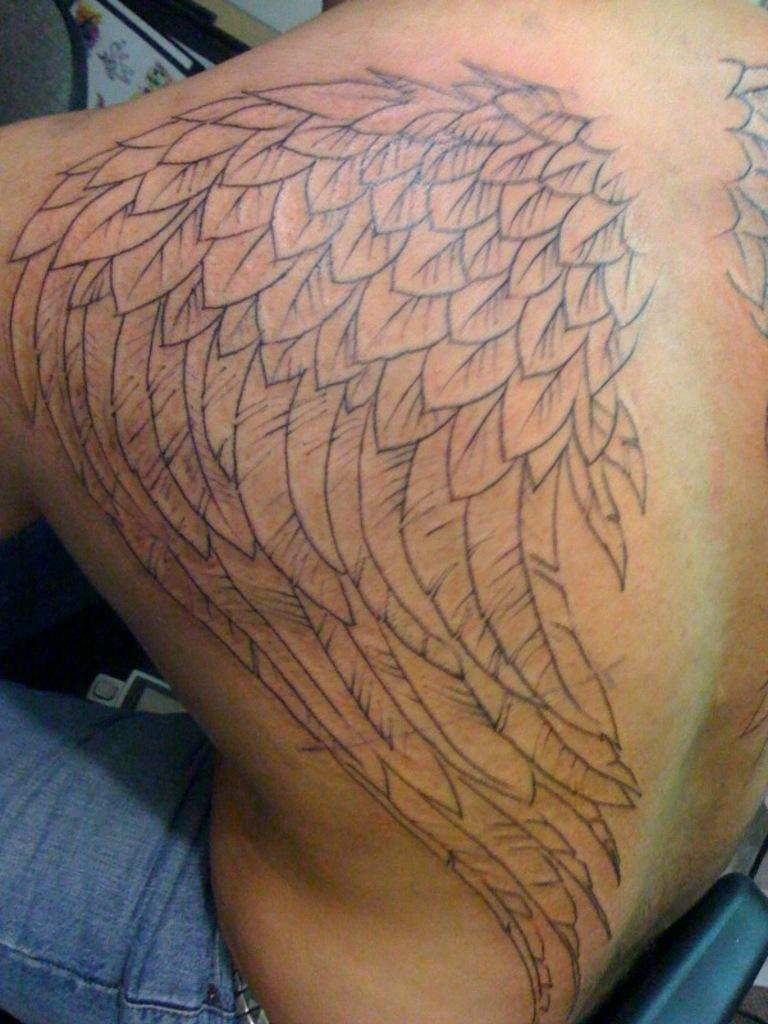What can be seen on a person's body in the image? There is a tattoo visible in the image. Can you describe the location of the tattoo on the person's body? The provided facts do not specify the location of the tattoo on the person's body. What type of calculator is being used by the birds in the image? There are no birds or calculators present in the image. 